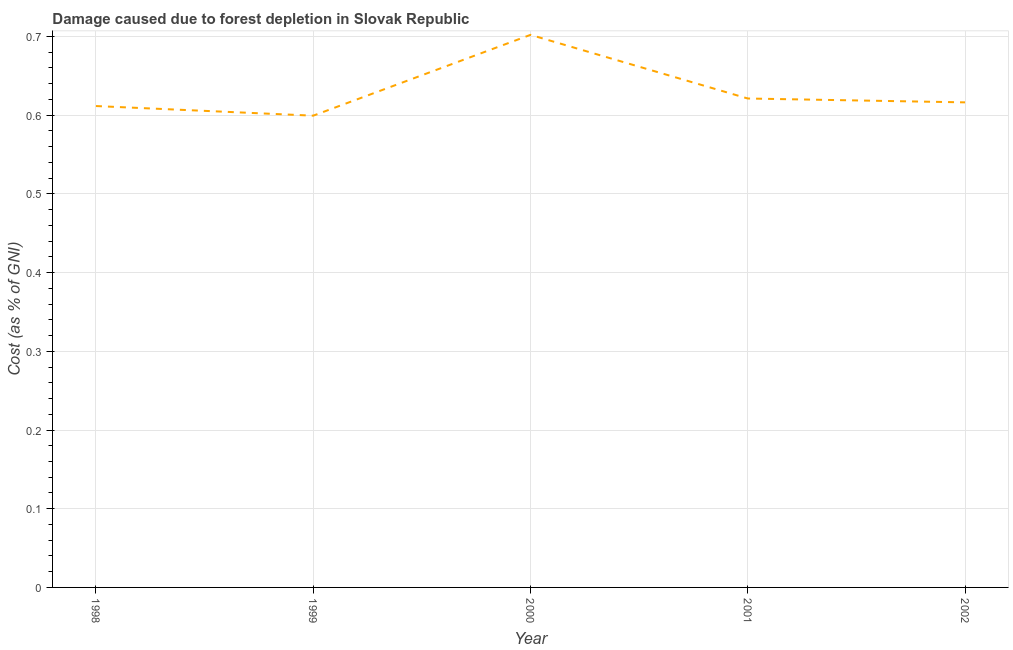What is the damage caused due to forest depletion in 2002?
Offer a very short reply. 0.62. Across all years, what is the maximum damage caused due to forest depletion?
Keep it short and to the point. 0.7. Across all years, what is the minimum damage caused due to forest depletion?
Keep it short and to the point. 0.6. What is the sum of the damage caused due to forest depletion?
Your answer should be compact. 3.15. What is the difference between the damage caused due to forest depletion in 2001 and 2002?
Offer a terse response. 0. What is the average damage caused due to forest depletion per year?
Keep it short and to the point. 0.63. What is the median damage caused due to forest depletion?
Your response must be concise. 0.62. In how many years, is the damage caused due to forest depletion greater than 0.04 %?
Your answer should be compact. 5. What is the ratio of the damage caused due to forest depletion in 1999 to that in 2002?
Offer a very short reply. 0.97. What is the difference between the highest and the second highest damage caused due to forest depletion?
Ensure brevity in your answer.  0.08. What is the difference between the highest and the lowest damage caused due to forest depletion?
Make the answer very short. 0.1. How many lines are there?
Keep it short and to the point. 1. Does the graph contain any zero values?
Offer a very short reply. No. Does the graph contain grids?
Make the answer very short. Yes. What is the title of the graph?
Provide a succinct answer. Damage caused due to forest depletion in Slovak Republic. What is the label or title of the X-axis?
Your answer should be very brief. Year. What is the label or title of the Y-axis?
Keep it short and to the point. Cost (as % of GNI). What is the Cost (as % of GNI) in 1998?
Keep it short and to the point. 0.61. What is the Cost (as % of GNI) in 1999?
Give a very brief answer. 0.6. What is the Cost (as % of GNI) of 2000?
Your response must be concise. 0.7. What is the Cost (as % of GNI) in 2001?
Your answer should be compact. 0.62. What is the Cost (as % of GNI) in 2002?
Offer a terse response. 0.62. What is the difference between the Cost (as % of GNI) in 1998 and 1999?
Your answer should be very brief. 0.01. What is the difference between the Cost (as % of GNI) in 1998 and 2000?
Make the answer very short. -0.09. What is the difference between the Cost (as % of GNI) in 1998 and 2001?
Give a very brief answer. -0.01. What is the difference between the Cost (as % of GNI) in 1998 and 2002?
Give a very brief answer. -0. What is the difference between the Cost (as % of GNI) in 1999 and 2000?
Provide a short and direct response. -0.1. What is the difference between the Cost (as % of GNI) in 1999 and 2001?
Provide a succinct answer. -0.02. What is the difference between the Cost (as % of GNI) in 1999 and 2002?
Offer a terse response. -0.02. What is the difference between the Cost (as % of GNI) in 2000 and 2001?
Give a very brief answer. 0.08. What is the difference between the Cost (as % of GNI) in 2000 and 2002?
Your answer should be very brief. 0.09. What is the difference between the Cost (as % of GNI) in 2001 and 2002?
Ensure brevity in your answer.  0. What is the ratio of the Cost (as % of GNI) in 1998 to that in 2000?
Make the answer very short. 0.87. What is the ratio of the Cost (as % of GNI) in 1999 to that in 2000?
Provide a succinct answer. 0.85. What is the ratio of the Cost (as % of GNI) in 1999 to that in 2001?
Give a very brief answer. 0.96. What is the ratio of the Cost (as % of GNI) in 1999 to that in 2002?
Make the answer very short. 0.97. What is the ratio of the Cost (as % of GNI) in 2000 to that in 2001?
Offer a terse response. 1.13. What is the ratio of the Cost (as % of GNI) in 2000 to that in 2002?
Offer a terse response. 1.14. 